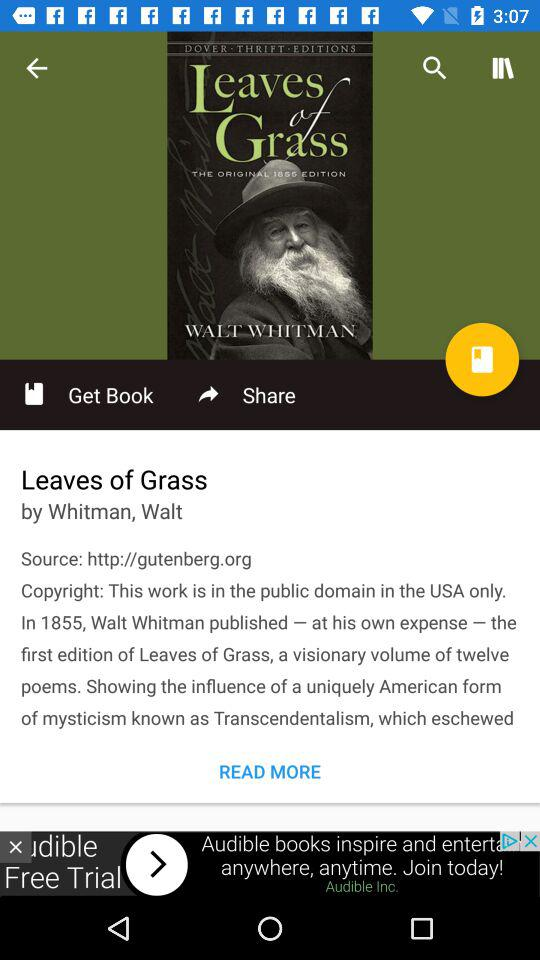Who is the author of the book "Leaves of Grass"? The author is Walt Whitman. 